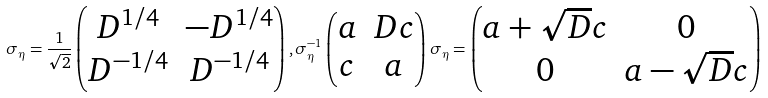<formula> <loc_0><loc_0><loc_500><loc_500>\sigma _ { \eta } = \frac { 1 } { \sqrt { 2 } } \begin{pmatrix} D ^ { 1 / 4 } & - D ^ { 1 / 4 } \\ D ^ { - 1 / 4 } & D ^ { - 1 / 4 } \end{pmatrix} , \sigma _ { \eta } ^ { - 1 } \begin{pmatrix} a & D c \\ c & a \end{pmatrix} \sigma _ { \eta } = \begin{pmatrix} a + \sqrt { D } c & 0 \\ 0 & a - \sqrt { D } c \end{pmatrix}</formula> 